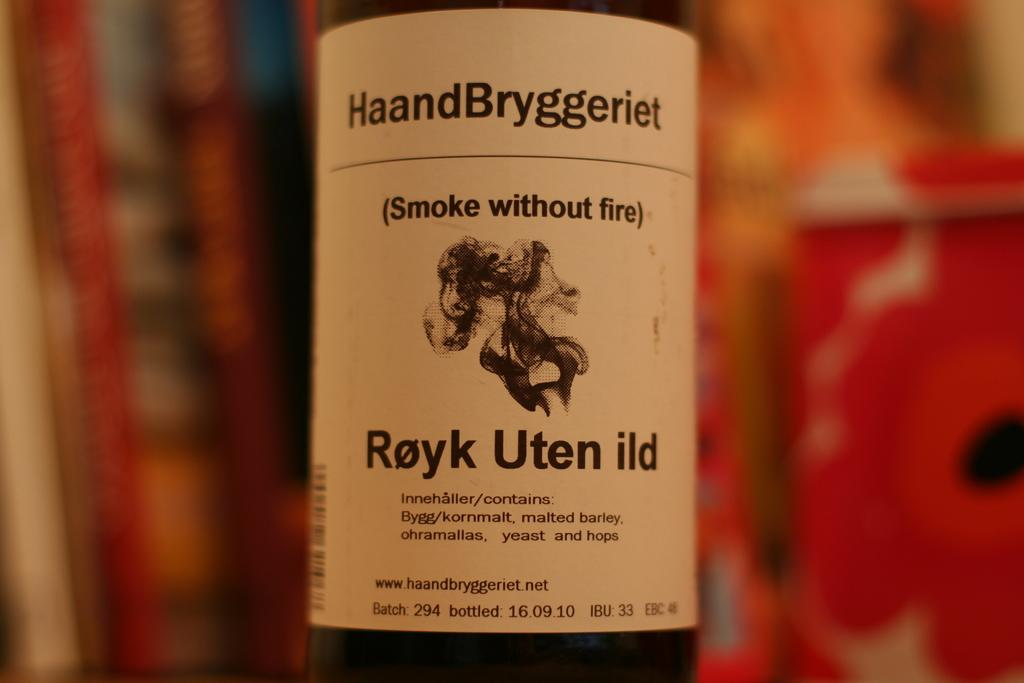<image>
Give a short and clear explanation of the subsequent image. A bottle has a white label that says Smoke without fire on it in parentheses. 